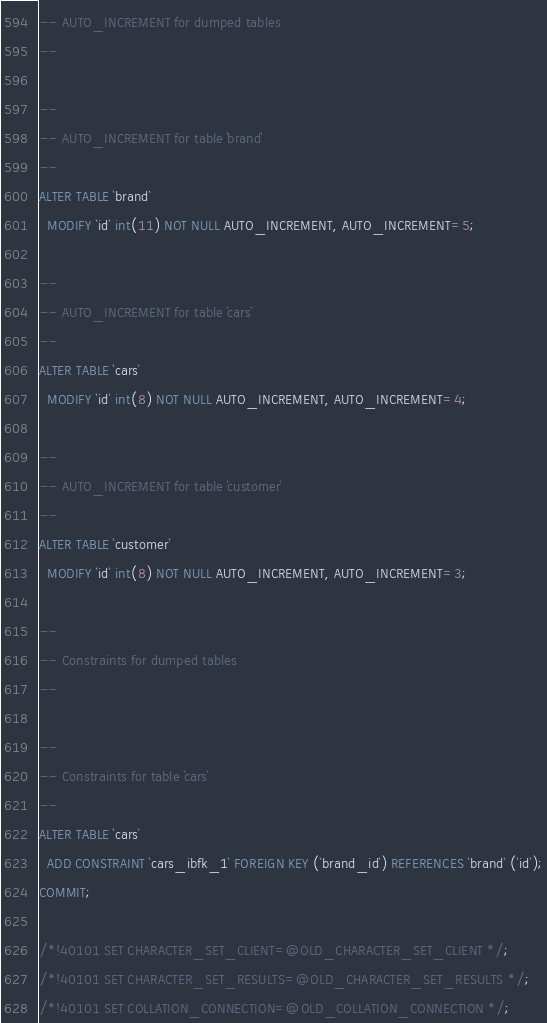<code> <loc_0><loc_0><loc_500><loc_500><_SQL_>-- AUTO_INCREMENT for dumped tables
--

--
-- AUTO_INCREMENT for table `brand`
--
ALTER TABLE `brand`
  MODIFY `id` int(11) NOT NULL AUTO_INCREMENT, AUTO_INCREMENT=5;

--
-- AUTO_INCREMENT for table `cars`
--
ALTER TABLE `cars`
  MODIFY `id` int(8) NOT NULL AUTO_INCREMENT, AUTO_INCREMENT=4;

--
-- AUTO_INCREMENT for table `customer`
--
ALTER TABLE `customer`
  MODIFY `id` int(8) NOT NULL AUTO_INCREMENT, AUTO_INCREMENT=3;

--
-- Constraints for dumped tables
--

--
-- Constraints for table `cars`
--
ALTER TABLE `cars`
  ADD CONSTRAINT `cars_ibfk_1` FOREIGN KEY (`brand_id`) REFERENCES `brand` (`id`);
COMMIT;

/*!40101 SET CHARACTER_SET_CLIENT=@OLD_CHARACTER_SET_CLIENT */;
/*!40101 SET CHARACTER_SET_RESULTS=@OLD_CHARACTER_SET_RESULTS */;
/*!40101 SET COLLATION_CONNECTION=@OLD_COLLATION_CONNECTION */;
</code> 